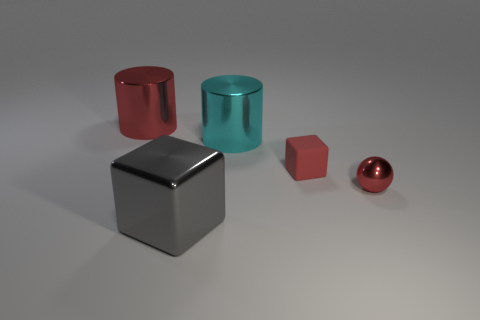Do the small rubber block and the shiny ball have the same color?
Your response must be concise. Yes. The small rubber object that is the same color as the tiny metal sphere is what shape?
Ensure brevity in your answer.  Cube. Are there fewer large cyan things that are in front of the gray thing than large shiny cylinders that are to the left of the big cyan cylinder?
Provide a succinct answer. Yes. What number of other things are the same material as the tiny red block?
Offer a very short reply. 0. Is the tiny red ball made of the same material as the gray block?
Ensure brevity in your answer.  Yes. What number of other objects are the same size as the cyan shiny thing?
Provide a succinct answer. 2. How big is the cube to the right of the cube in front of the red matte block?
Provide a succinct answer. Small. What is the color of the big metal thing in front of the red metallic thing in front of the cylinder left of the cyan shiny object?
Offer a very short reply. Gray. There is a red thing that is on the right side of the gray block and to the left of the tiny red ball; what is its size?
Your answer should be very brief. Small. How many other objects are the same shape as the big red thing?
Offer a terse response. 1. 